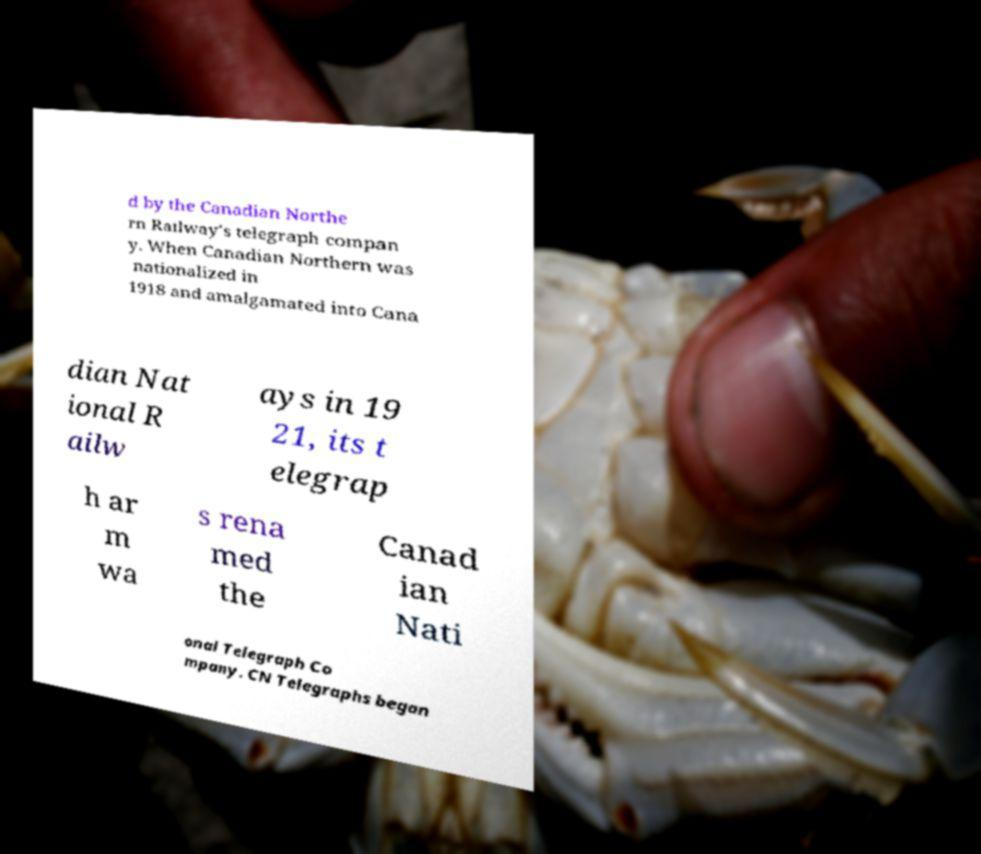I need the written content from this picture converted into text. Can you do that? d by the Canadian Northe rn Railway's telegraph compan y. When Canadian Northern was nationalized in 1918 and amalgamated into Cana dian Nat ional R ailw ays in 19 21, its t elegrap h ar m wa s rena med the Canad ian Nati onal Telegraph Co mpany. CN Telegraphs began 